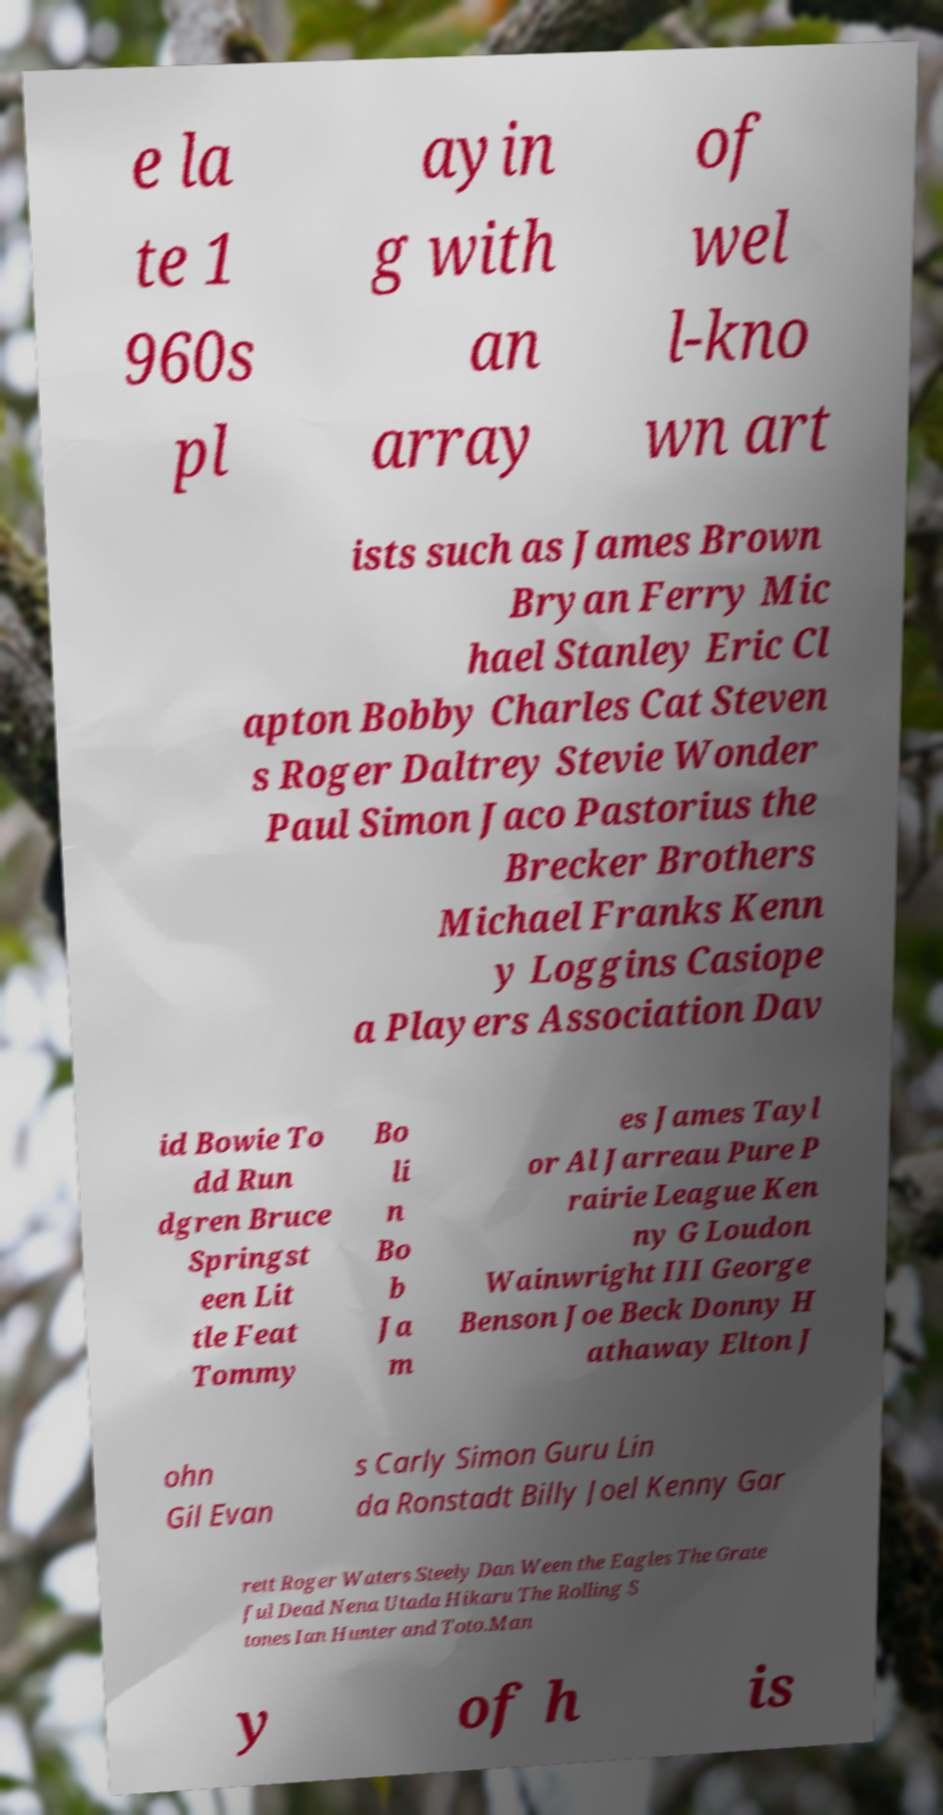There's text embedded in this image that I need extracted. Can you transcribe it verbatim? e la te 1 960s pl ayin g with an array of wel l-kno wn art ists such as James Brown Bryan Ferry Mic hael Stanley Eric Cl apton Bobby Charles Cat Steven s Roger Daltrey Stevie Wonder Paul Simon Jaco Pastorius the Brecker Brothers Michael Franks Kenn y Loggins Casiope a Players Association Dav id Bowie To dd Run dgren Bruce Springst een Lit tle Feat Tommy Bo li n Bo b Ja m es James Tayl or Al Jarreau Pure P rairie League Ken ny G Loudon Wainwright III George Benson Joe Beck Donny H athaway Elton J ohn Gil Evan s Carly Simon Guru Lin da Ronstadt Billy Joel Kenny Gar rett Roger Waters Steely Dan Ween the Eagles The Grate ful Dead Nena Utada Hikaru The Rolling S tones Ian Hunter and Toto.Man y of h is 